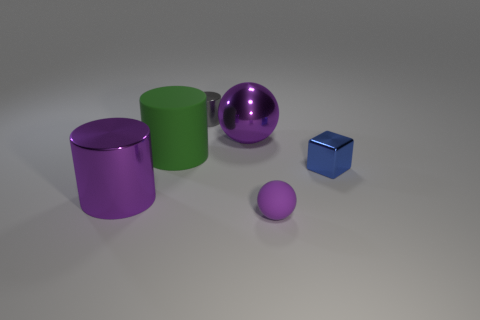Subtract all tiny shiny cylinders. How many cylinders are left? 2 Add 1 brown metallic blocks. How many objects exist? 7 Subtract all blocks. How many objects are left? 5 Subtract all gray cylinders. How many cylinders are left? 2 Subtract 0 red cylinders. How many objects are left? 6 Subtract 2 balls. How many balls are left? 0 Subtract all brown cylinders. Subtract all cyan balls. How many cylinders are left? 3 Subtract all brown cubes. How many purple cylinders are left? 1 Subtract all purple balls. Subtract all purple balls. How many objects are left? 2 Add 2 metal balls. How many metal balls are left? 3 